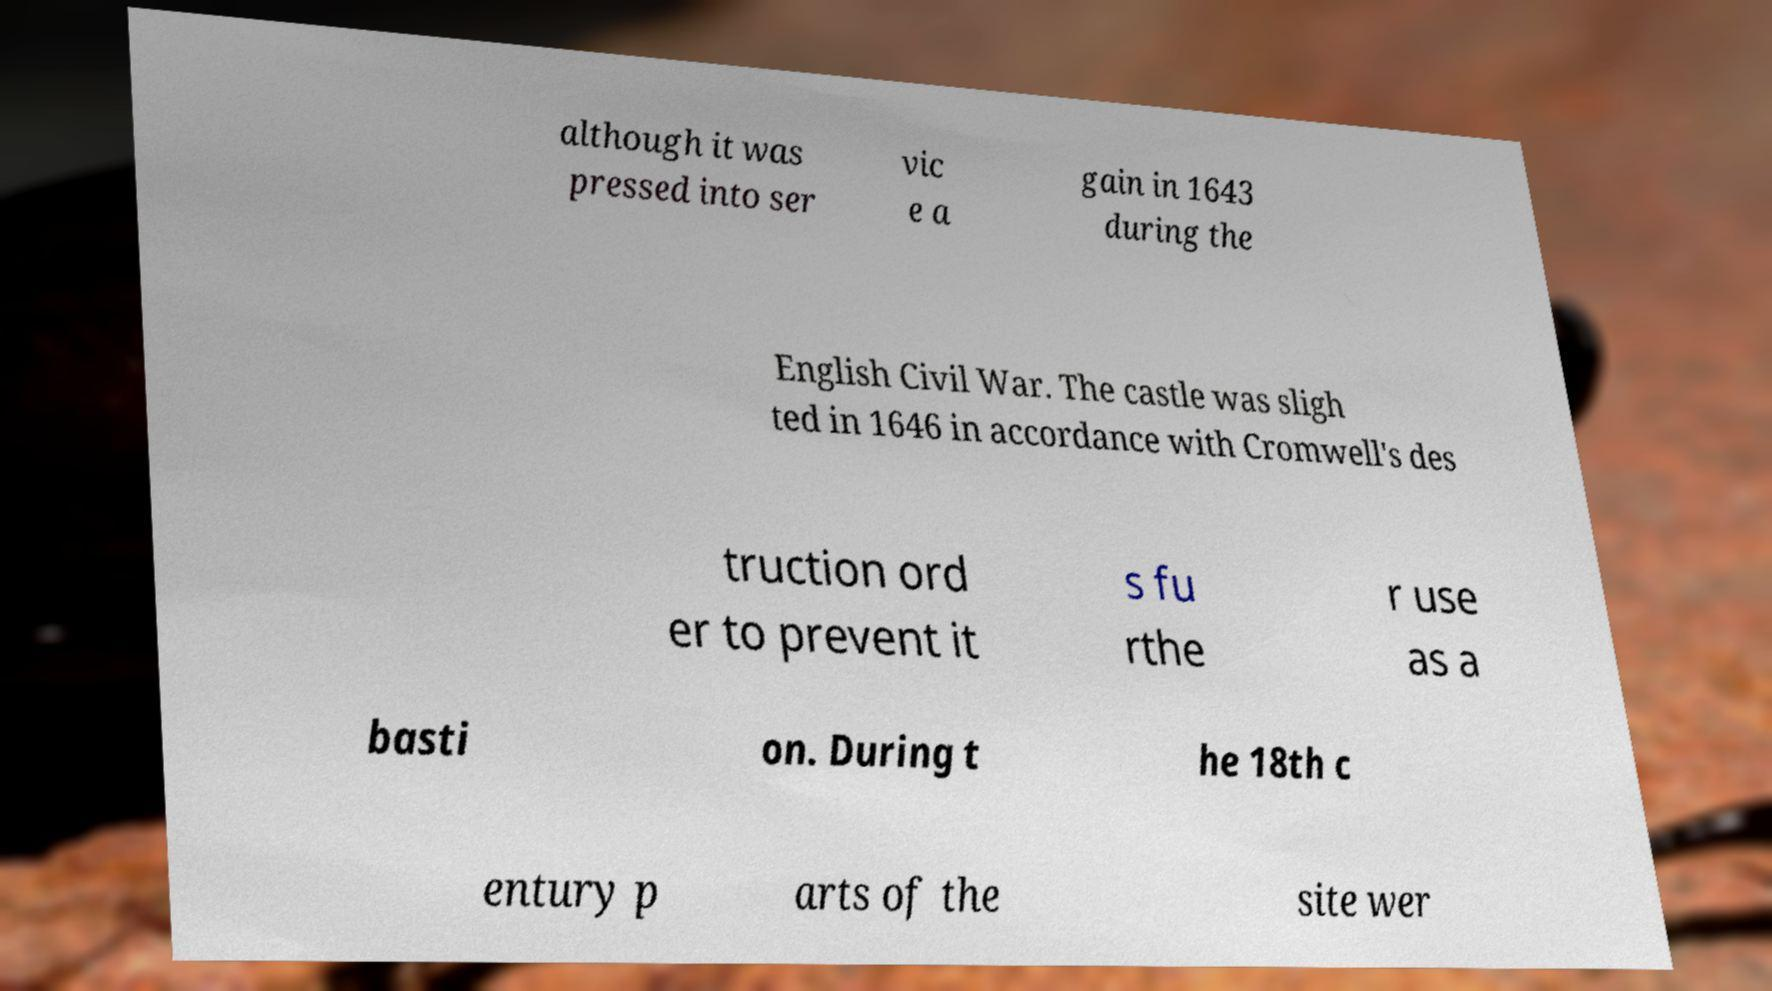Can you accurately transcribe the text from the provided image for me? although it was pressed into ser vic e a gain in 1643 during the English Civil War. The castle was sligh ted in 1646 in accordance with Cromwell's des truction ord er to prevent it s fu rthe r use as a basti on. During t he 18th c entury p arts of the site wer 